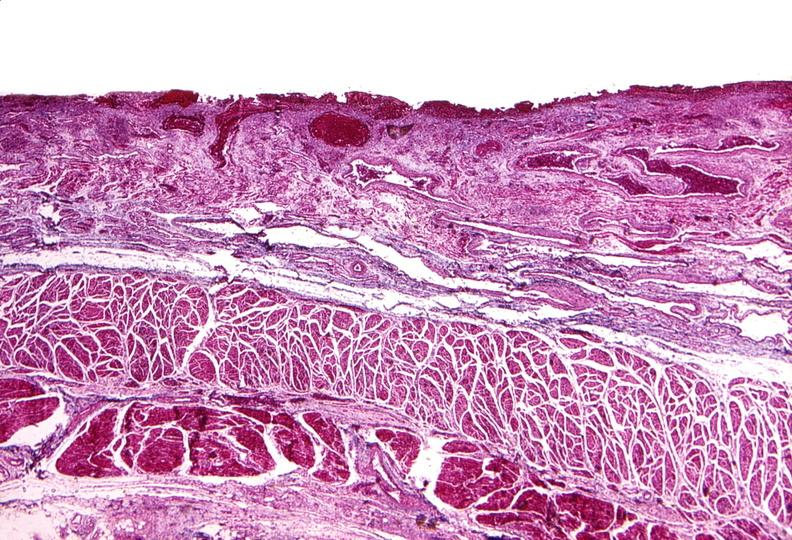what is present?
Answer the question using a single word or phrase. Gastrointestinal 